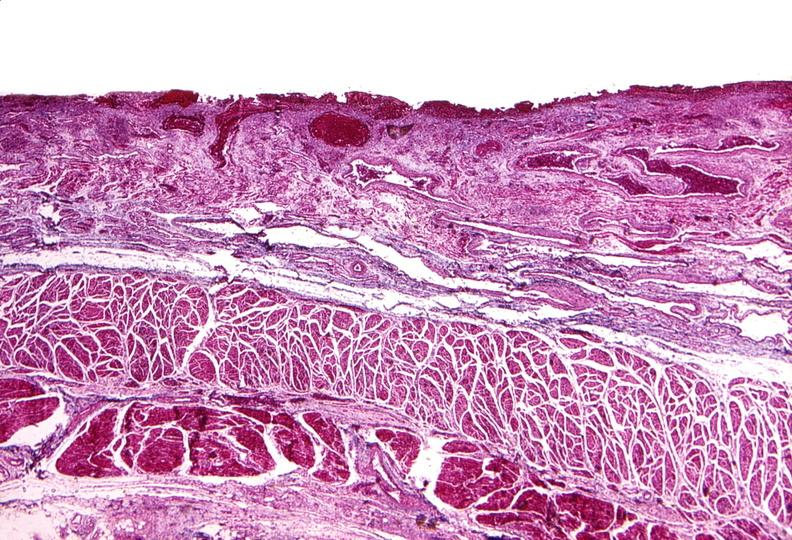what is present?
Answer the question using a single word or phrase. Gastrointestinal 